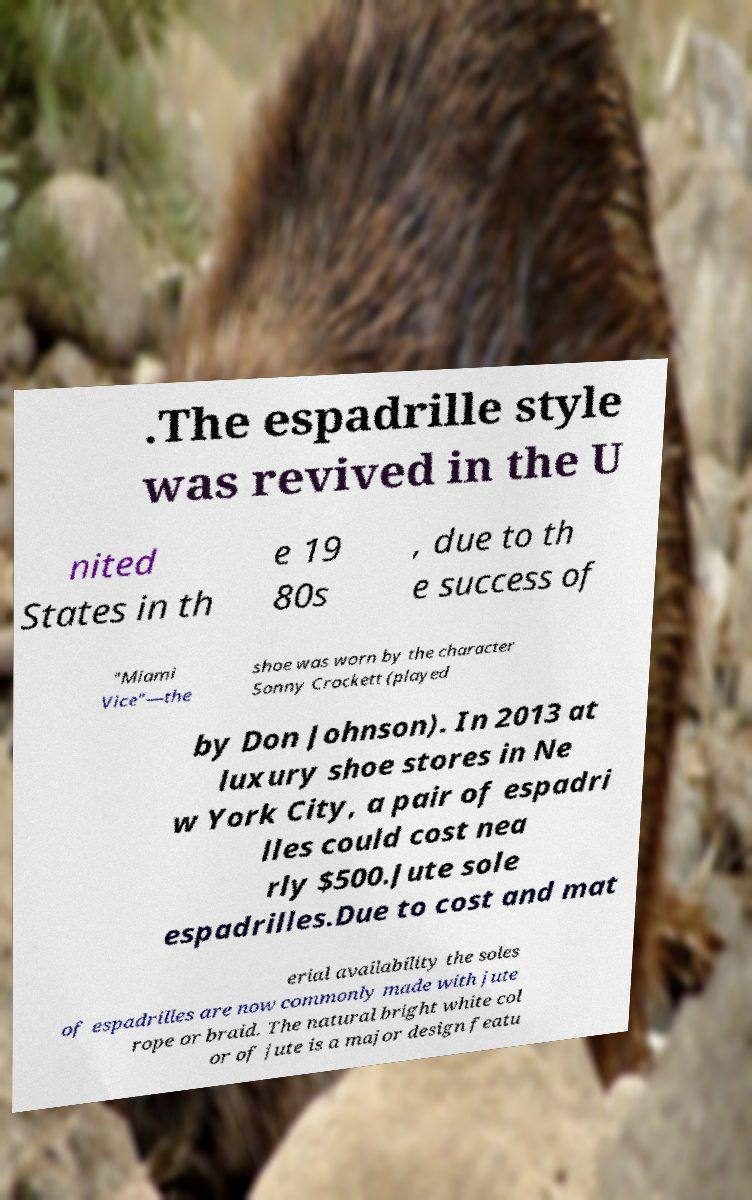Can you accurately transcribe the text from the provided image for me? .The espadrille style was revived in the U nited States in th e 19 80s , due to th e success of "Miami Vice"—the shoe was worn by the character Sonny Crockett (played by Don Johnson). In 2013 at luxury shoe stores in Ne w York City, a pair of espadri lles could cost nea rly $500.Jute sole espadrilles.Due to cost and mat erial availability the soles of espadrilles are now commonly made with jute rope or braid. The natural bright white col or of jute is a major design featu 